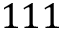Convert formula to latex. <formula><loc_0><loc_0><loc_500><loc_500>1 1 1</formula> 